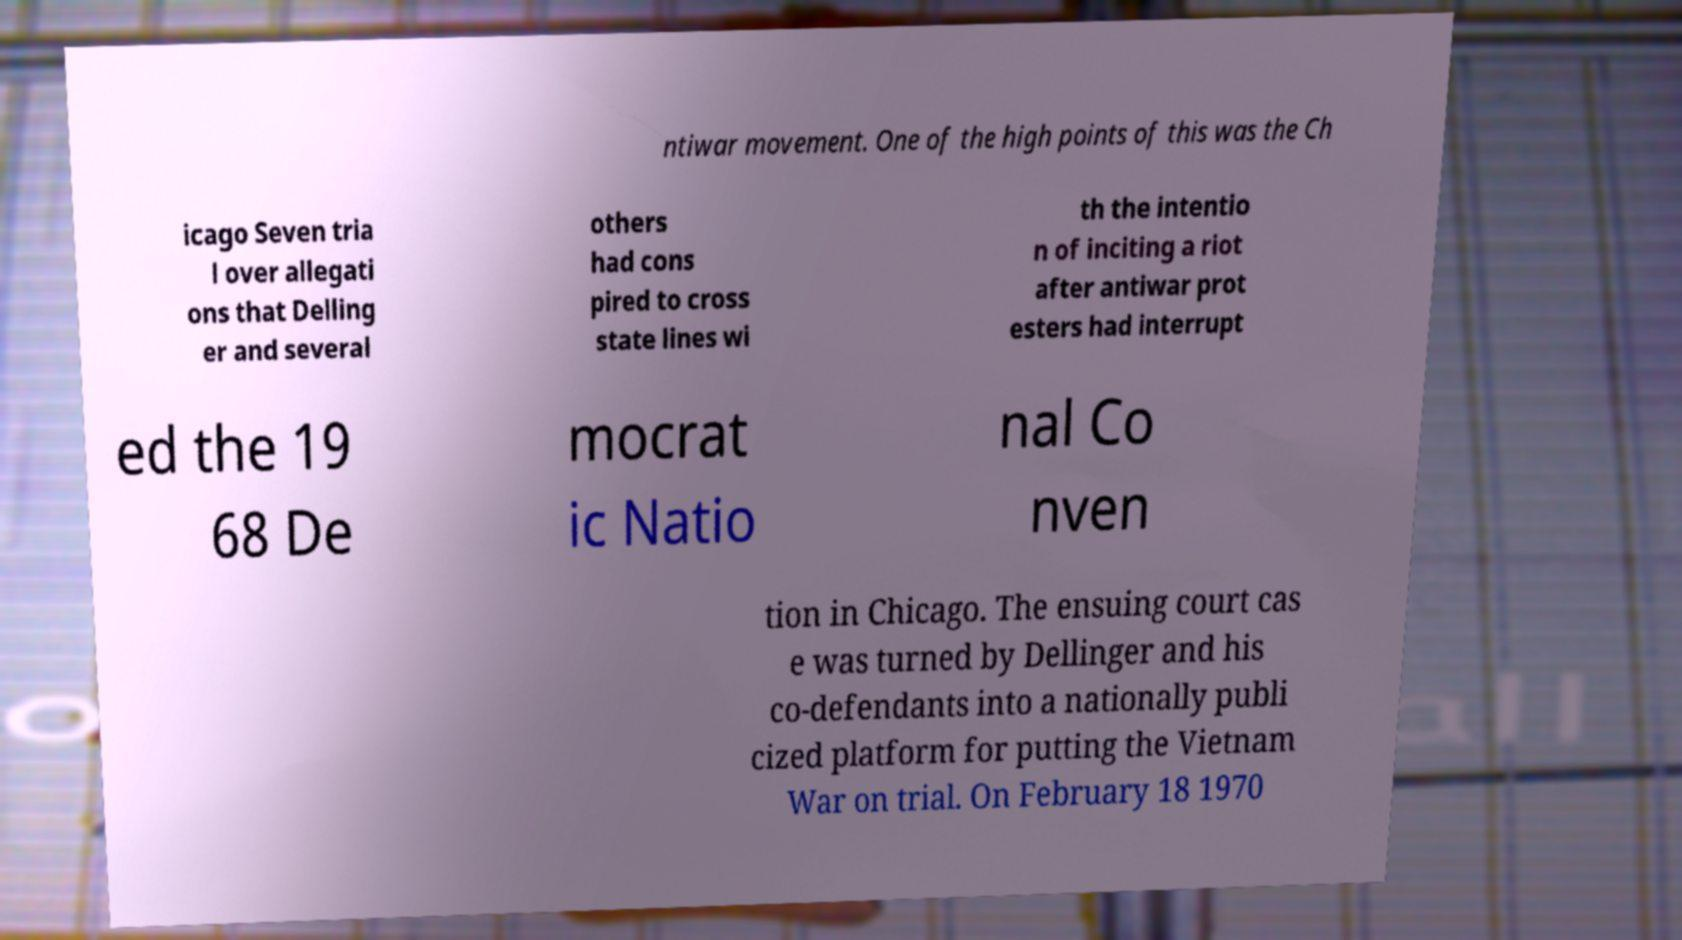Could you extract and type out the text from this image? ntiwar movement. One of the high points of this was the Ch icago Seven tria l over allegati ons that Delling er and several others had cons pired to cross state lines wi th the intentio n of inciting a riot after antiwar prot esters had interrupt ed the 19 68 De mocrat ic Natio nal Co nven tion in Chicago. The ensuing court cas e was turned by Dellinger and his co-defendants into a nationally publi cized platform for putting the Vietnam War on trial. On February 18 1970 